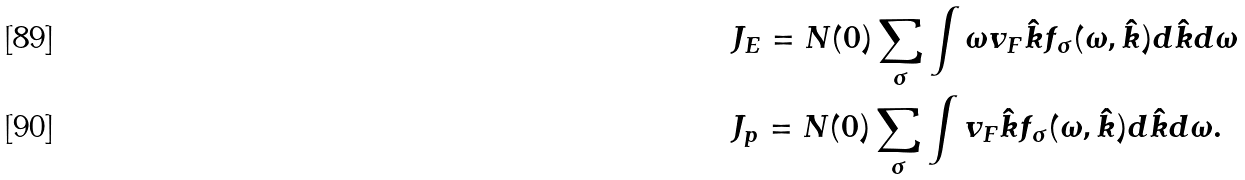Convert formula to latex. <formula><loc_0><loc_0><loc_500><loc_500>& J _ { E } = N ( 0 ) \sum _ { \sigma } \int \omega v _ { F } \hat { k } f _ { \sigma } ( \omega , \hat { k } ) d \hat { k } d \omega \\ & J _ { p } = N ( 0 ) \sum _ { \sigma } \int v _ { F } \hat { k } f _ { \sigma } ( \omega , \hat { k } ) d \hat { k } d \omega .</formula> 